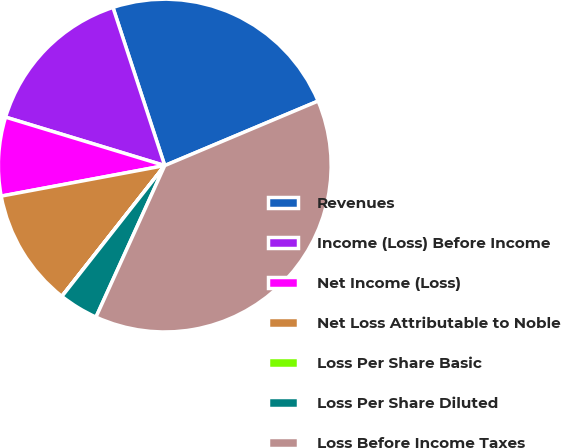Convert chart. <chart><loc_0><loc_0><loc_500><loc_500><pie_chart><fcel>Revenues<fcel>Income (Loss) Before Income<fcel>Net Income (Loss)<fcel>Net Loss Attributable to Noble<fcel>Loss Per Share Basic<fcel>Loss Per Share Diluted<fcel>Loss Before Income Taxes<nl><fcel>23.7%<fcel>15.26%<fcel>7.64%<fcel>11.45%<fcel>0.01%<fcel>3.82%<fcel>38.12%<nl></chart> 